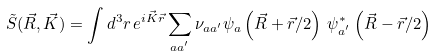Convert formula to latex. <formula><loc_0><loc_0><loc_500><loc_500>\tilde { S } ( \vec { R } , \vec { K } ) = \int d ^ { 3 } r \, e ^ { i \vec { K } \vec { r } } \sum _ { a a ^ { ^ { \prime } } } \nu _ { a a { ^ { \prime } } } \psi _ { a } \left ( \vec { R } + \vec { r } / 2 \right ) \, \psi ^ { * } _ { a ^ { ^ { \prime } } } \left ( \vec { R } - \vec { r } / 2 \right )</formula> 